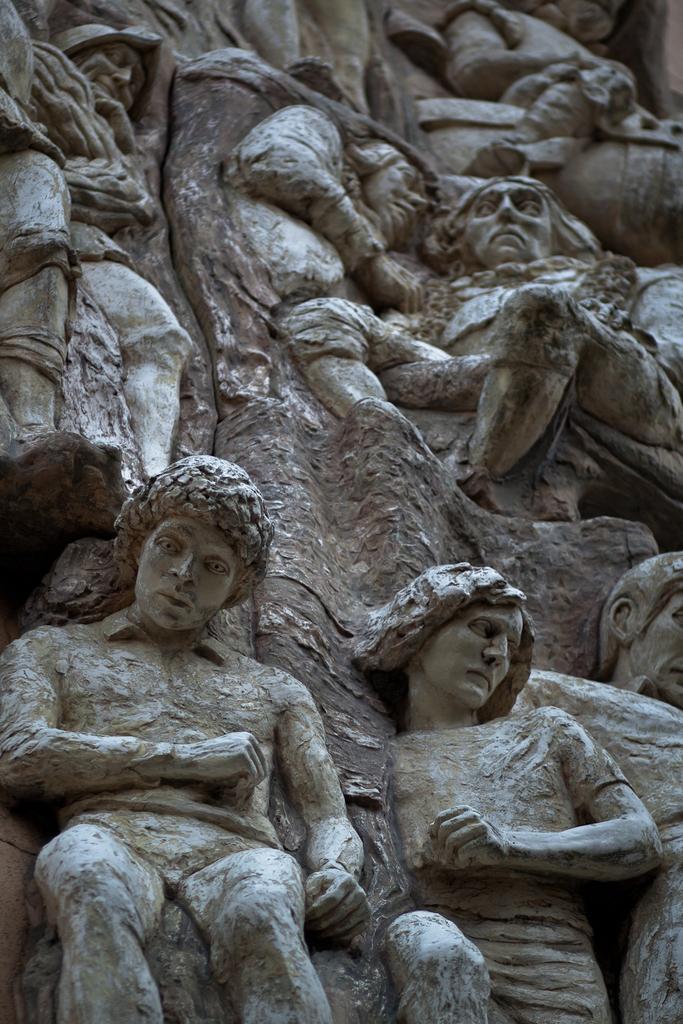How would you summarize this image in a sentence or two? In this image I can see few people statues in grey color. 